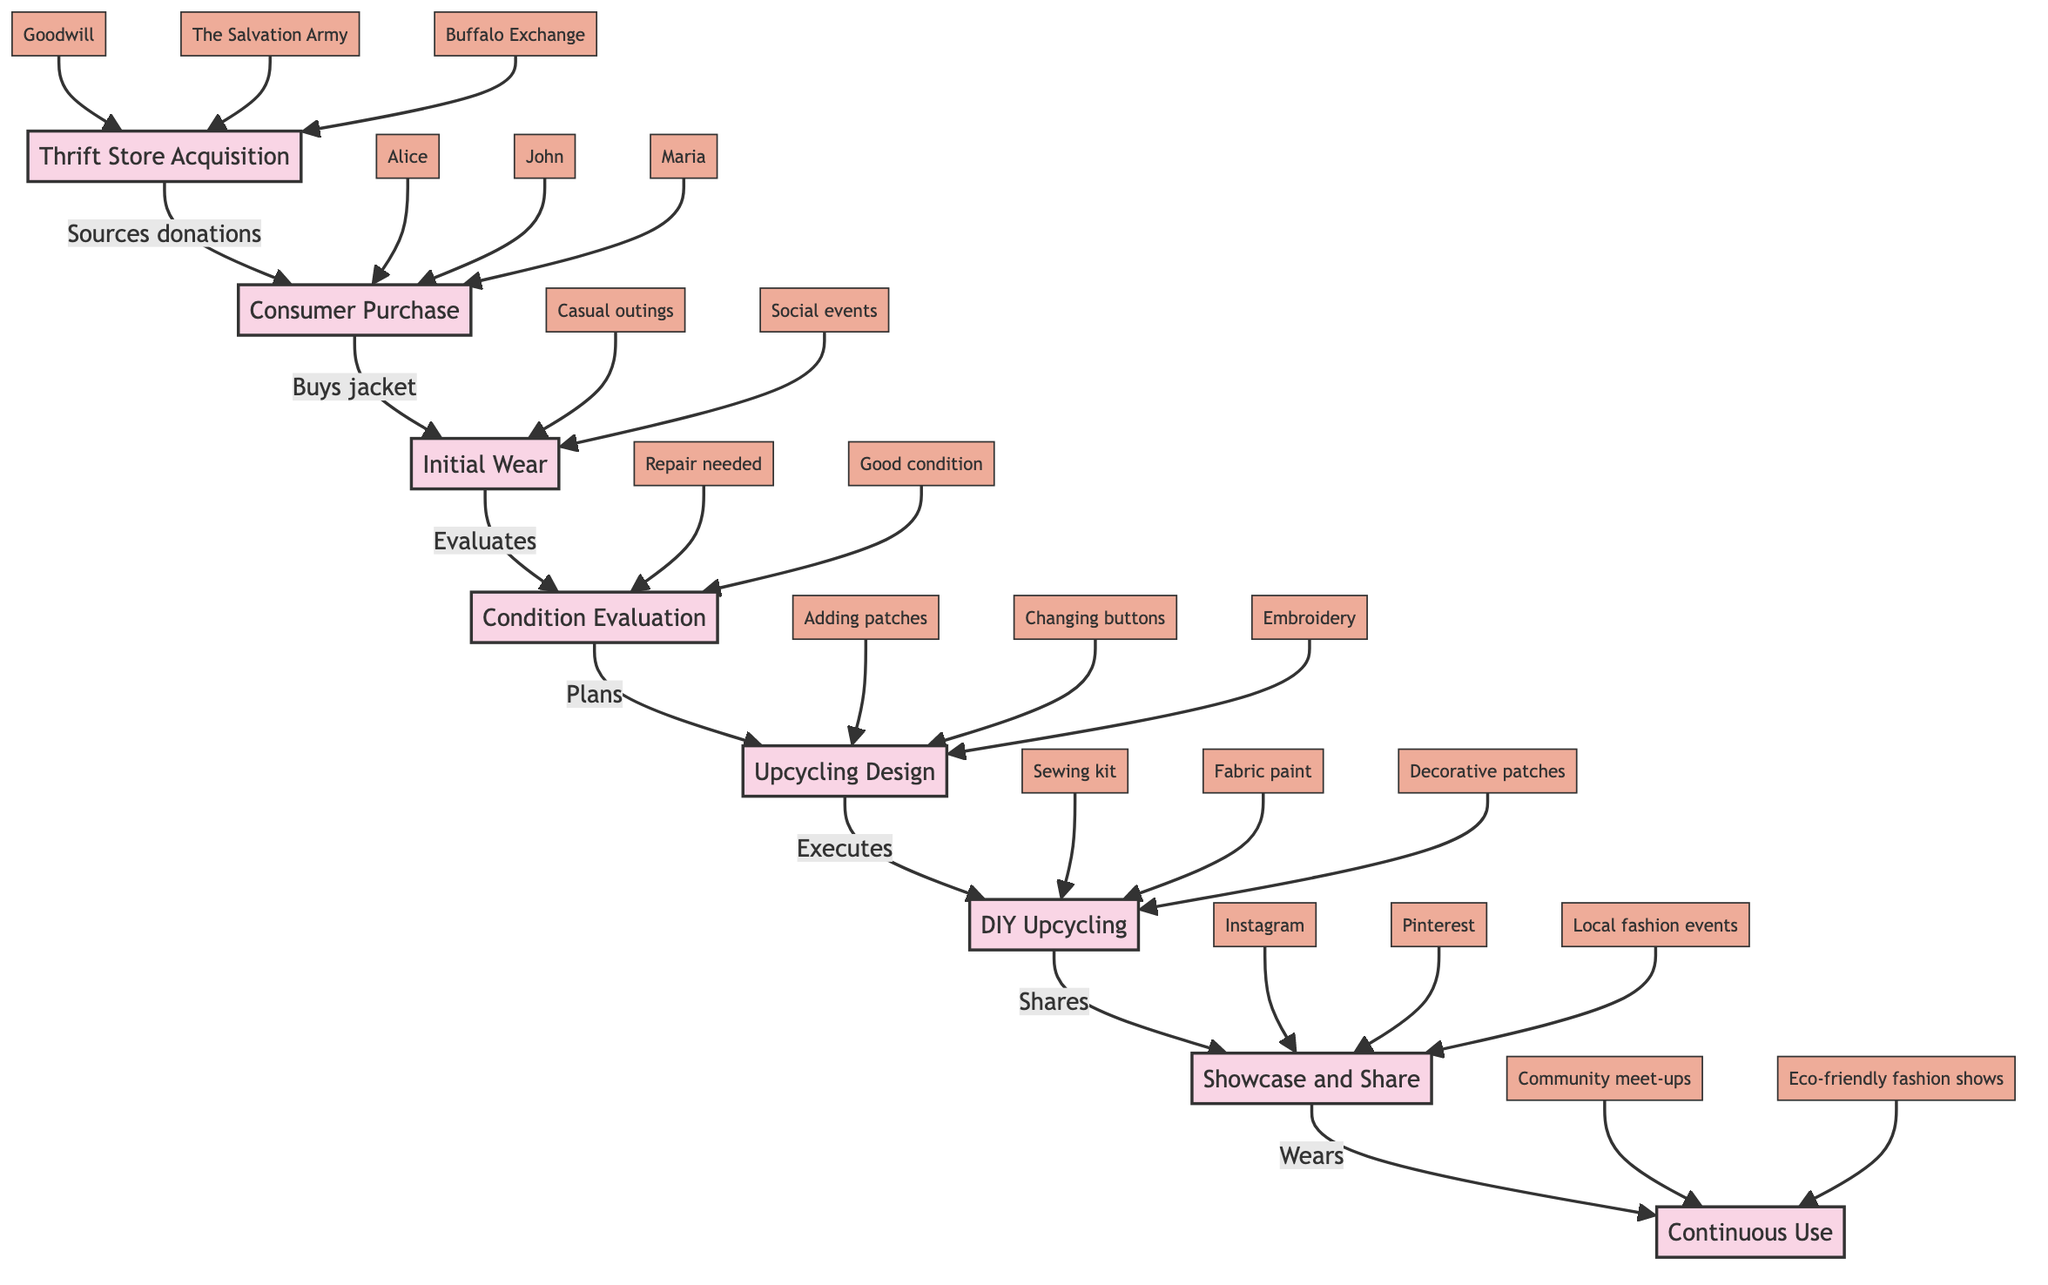What is the first stage of the journey? The diagram starts with "Thrift Store Acquisition," which is the first node in the flowchart, indicating the initial step in the journey of a second-hand leather jacket.
Answer: Thrift Store Acquisition Who are the consumers involved in the purchase? The consumers mentioned in the diagram are "Alice," "John," and "Maria," who are linked to the "Consumer Purchase" node as they buy the jacket.
Answer: Alice, John, Maria What does the condition evaluation step assess? The step labeled "Condition Evaluation" has two potential outcomes: "Repair needed" and "Good condition," indicating what condition the jacket is in after evaluation.
Answer: Repair needed, Good condition How many upcycling design plans are mentioned? There are three plans listed under the "Upcycling Design" step: "Adding patches," "Changing buttons," and "Embroidery," showing the various options for upcycling.
Answer: 3 What social media platforms are used to showcase the upcycled jacket? The diagram shows three platforms for showcasing: "Instagram," "Pinterest," and "Local fashion events," indicating where the upcycled jacket can be shared.
Answer: Instagram, Pinterest, Local fashion events What is the final step in the journey? The last node in the diagram is "Continuous Use," which represents the ongoing process of wearing and enjoying the upcycled jacket after it has been shared and showcased.
Answer: Continuous Use What tools are used during DIY upcycling? The "DIY Upcycling" step lists three tools: "Sewing kit," "Fabric paint," and "Decorative patches," indicating what tools are necessary for upcycling activities.
Answer: Sewing kit, Fabric paint, Decorative patches How many thrift stores are mentioned as sources of acquisition? The diagram identifies three thrift stores: "Goodwill," "The Salvation Army," and "Buffalo Exchange," showing the various potential sources from which the jacket can be acquired.
Answer: 3 What types of events can the upcycled jacket be worn to? The final node "Continuous Use" includes two types of events: "Community meet-ups" and "Eco-friendly fashion shows," indicating suitable occasions for wearing the jacket.
Answer: Community meet-ups, Eco-friendly fashion shows 